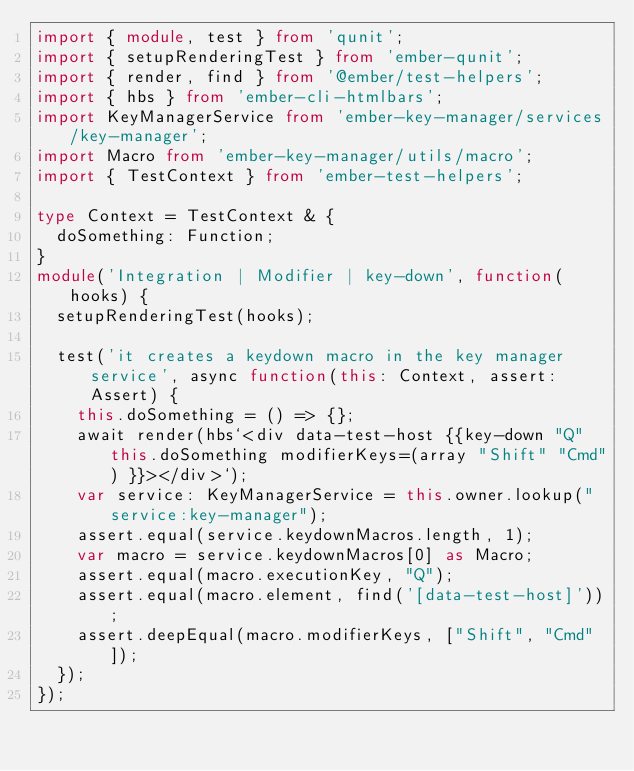<code> <loc_0><loc_0><loc_500><loc_500><_TypeScript_>import { module, test } from 'qunit';
import { setupRenderingTest } from 'ember-qunit';
import { render, find } from '@ember/test-helpers';
import { hbs } from 'ember-cli-htmlbars';
import KeyManagerService from 'ember-key-manager/services/key-manager';
import Macro from 'ember-key-manager/utils/macro';
import { TestContext } from 'ember-test-helpers';

type Context = TestContext & {
  doSomething: Function;
}
module('Integration | Modifier | key-down', function(hooks) {
  setupRenderingTest(hooks);

  test('it creates a keydown macro in the key manager service', async function(this: Context, assert: Assert) {
    this.doSomething = () => {};
    await render(hbs`<div data-test-host {{key-down "Q" this.doSomething modifierKeys=(array "Shift" "Cmd") }}></div>`);
    var service: KeyManagerService = this.owner.lookup("service:key-manager");
    assert.equal(service.keydownMacros.length, 1);
    var macro = service.keydownMacros[0] as Macro;
    assert.equal(macro.executionKey, "Q");
    assert.equal(macro.element, find('[data-test-host]'));
    assert.deepEqual(macro.modifierKeys, ["Shift", "Cmd"]);
  });
});
</code> 